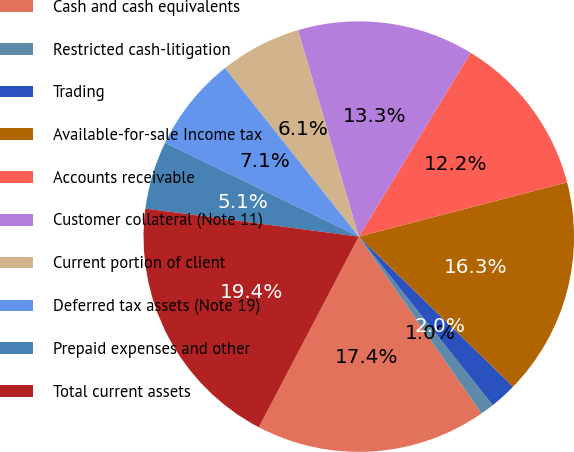<chart> <loc_0><loc_0><loc_500><loc_500><pie_chart><fcel>Cash and cash equivalents<fcel>Restricted cash-litigation<fcel>Trading<fcel>Available-for-sale Income tax<fcel>Accounts receivable<fcel>Customer collateral (Note 11)<fcel>Current portion of client<fcel>Deferred tax assets (Note 19)<fcel>Prepaid expenses and other<fcel>Total current assets<nl><fcel>17.35%<fcel>1.02%<fcel>2.04%<fcel>16.33%<fcel>12.24%<fcel>13.26%<fcel>6.12%<fcel>7.14%<fcel>5.1%<fcel>19.39%<nl></chart> 